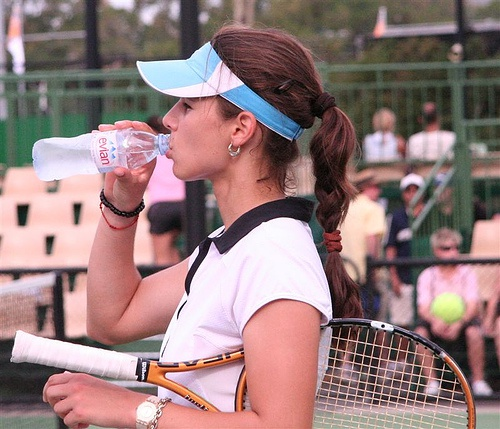Describe the objects in this image and their specific colors. I can see people in darkgray, salmon, lavender, brown, and black tones, tennis racket in darkgray, lavender, black, and gray tones, people in darkgray, brown, pink, lightpink, and black tones, bottle in darkgray, lavender, pink, and lightpink tones, and bench in darkgray, pink, lightpink, gray, and black tones in this image. 